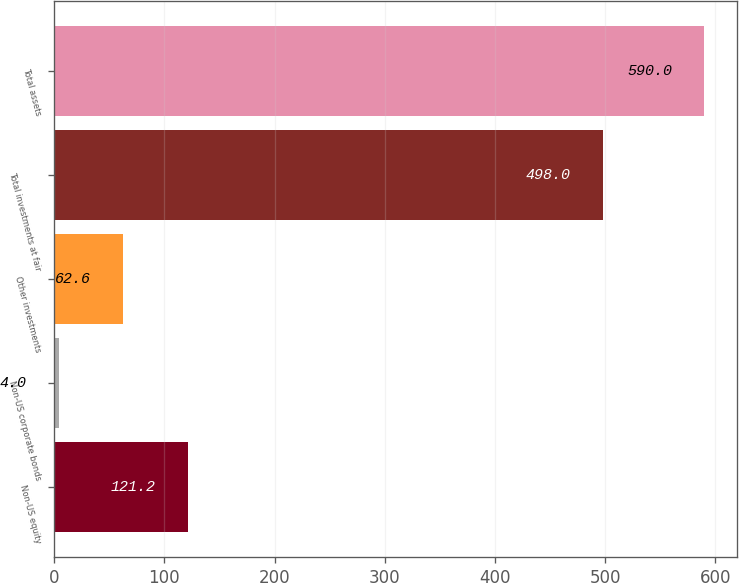Convert chart to OTSL. <chart><loc_0><loc_0><loc_500><loc_500><bar_chart><fcel>Non-US equity<fcel>Non-US corporate bonds<fcel>Other investments<fcel>Total investments at fair<fcel>Total assets<nl><fcel>121.2<fcel>4<fcel>62.6<fcel>498<fcel>590<nl></chart> 